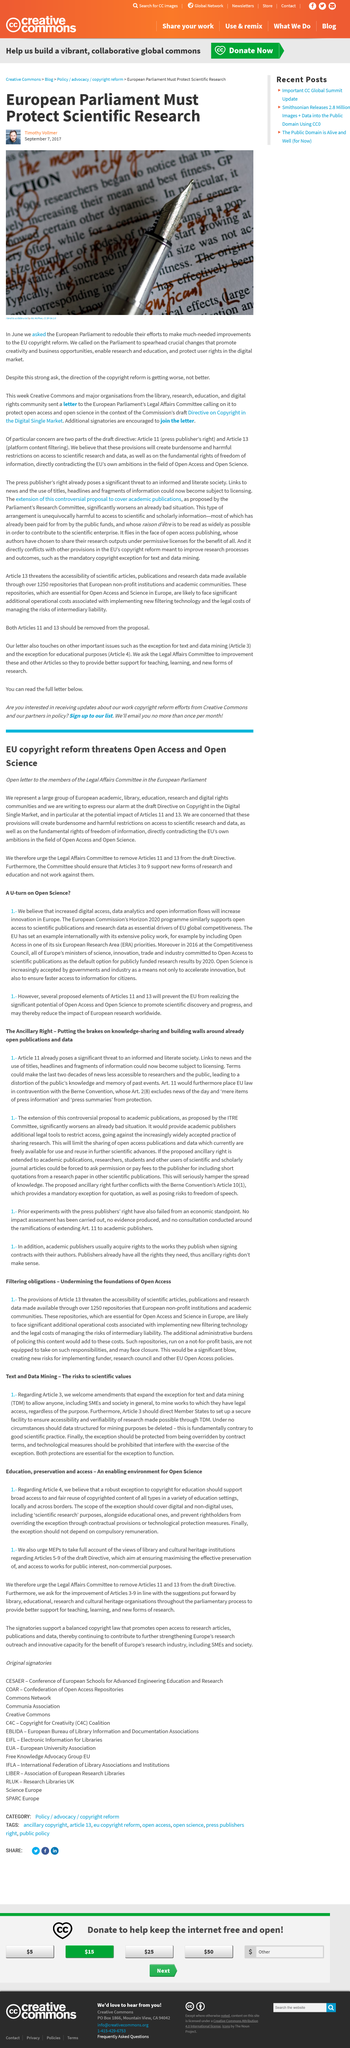Specify some key components in this picture. It is against good scientific practice to delete this data structure as it is not in line with the principles of accuracy, integrity, and preservation of data. The author of the article "European Parliament Must Protect Scientific Research" is Timothy Vollmer. We, the authors, represent a diverse group of European academic, library, education, research, and digital rights organizations. This article was published on September 7th, 2017. The direction of copyright reform is not improving, but instead is deteriorating. 